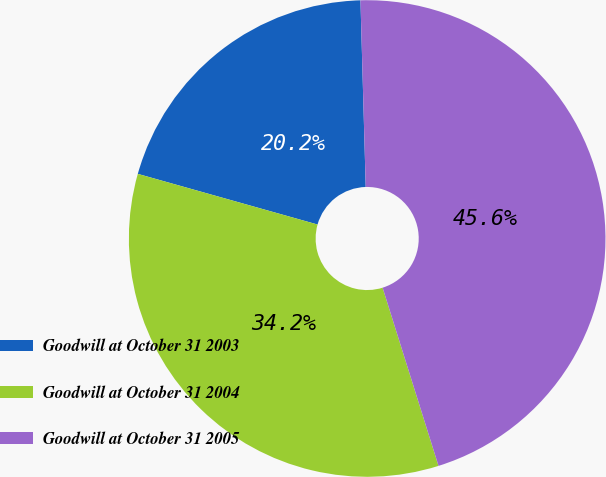Convert chart. <chart><loc_0><loc_0><loc_500><loc_500><pie_chart><fcel>Goodwill at October 31 2003<fcel>Goodwill at October 31 2004<fcel>Goodwill at October 31 2005<nl><fcel>20.18%<fcel>34.21%<fcel>45.61%<nl></chart> 